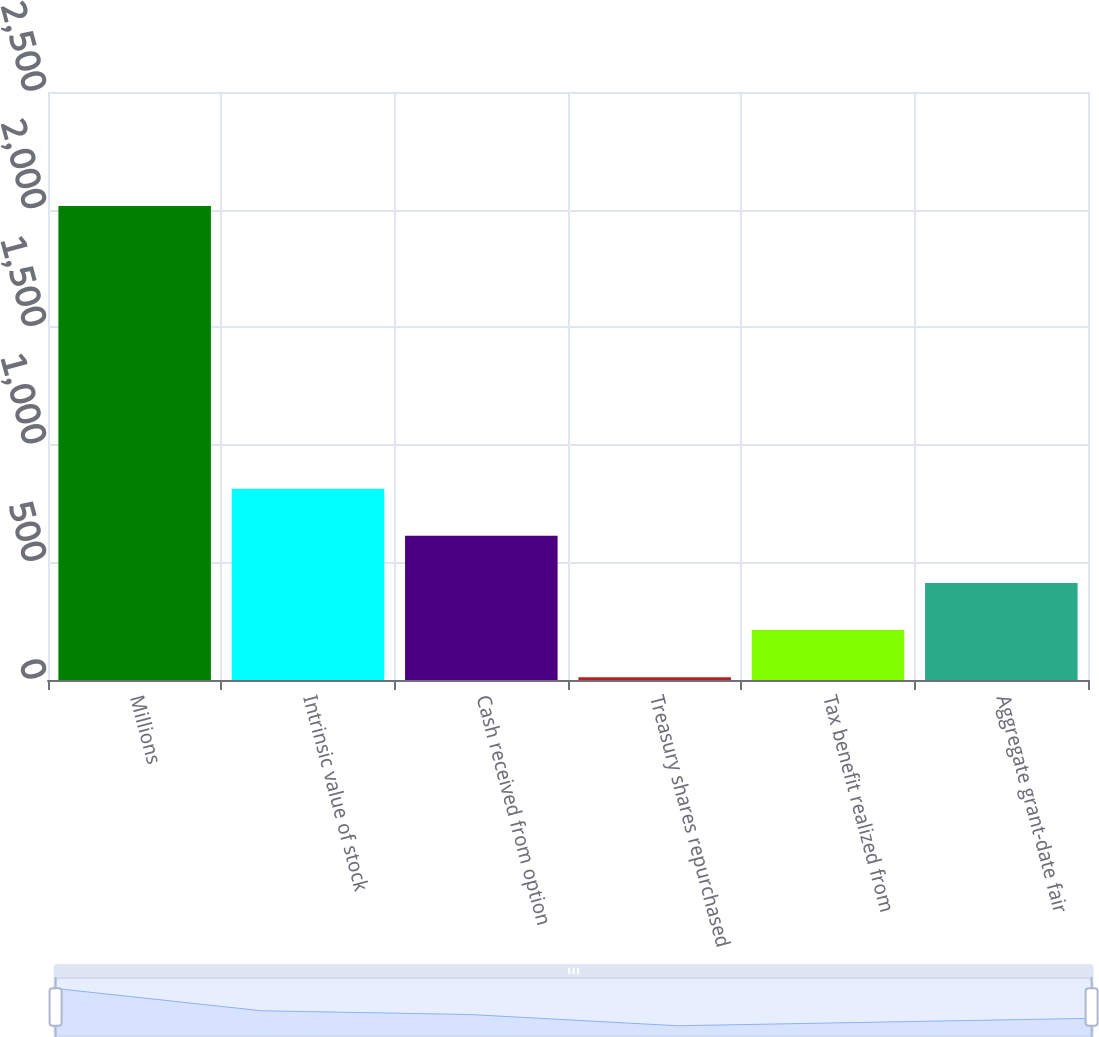Convert chart to OTSL. <chart><loc_0><loc_0><loc_500><loc_500><bar_chart><fcel>Millions<fcel>Intrinsic value of stock<fcel>Cash received from option<fcel>Treasury shares repurchased<fcel>Tax benefit realized from<fcel>Aggregate grant-date fair<nl><fcel>2015<fcel>813.2<fcel>612.9<fcel>12<fcel>212.3<fcel>412.6<nl></chart> 